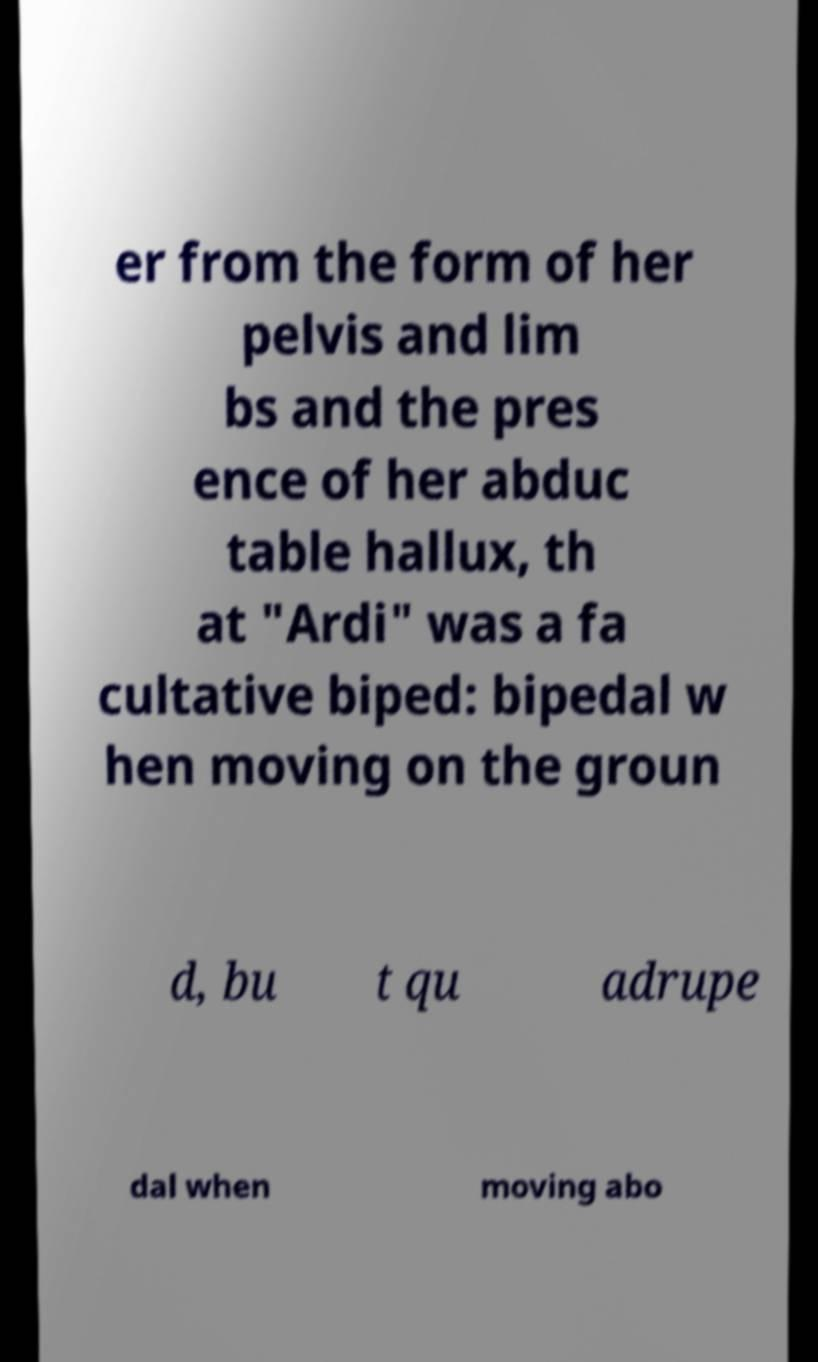I need the written content from this picture converted into text. Can you do that? er from the form of her pelvis and lim bs and the pres ence of her abduc table hallux, th at "Ardi" was a fa cultative biped: bipedal w hen moving on the groun d, bu t qu adrupe dal when moving abo 